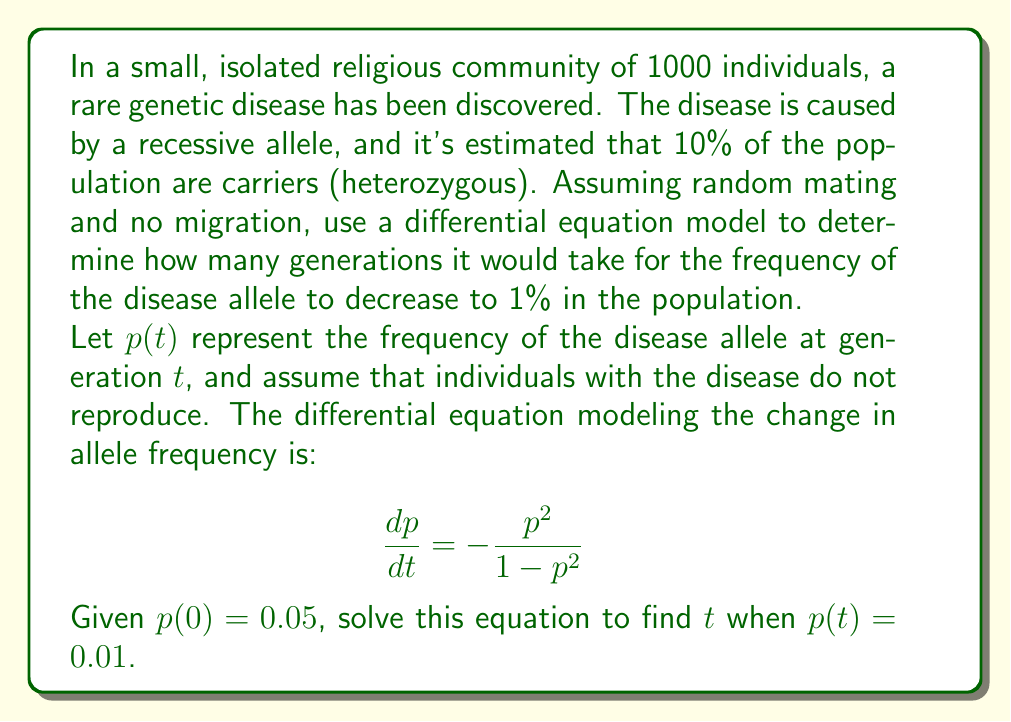Help me with this question. Let's approach this step-by-step:

1) First, we need to separate variables in the differential equation:

   $$\frac{dp}{dt} = -\frac{p^2}{1-p^2}$$
   $$dt = -\frac{1-p^2}{p^2}dp$$

2) Now, we integrate both sides:

   $$\int dt = -\int \frac{1-p^2}{p^2}dp$$

3) The right-hand side can be integrated using partial fractions:

   $$t + C = \frac{1}{p} + \ln(p) + C$$

4) We can determine the constant $C$ using the initial condition $p(0) = 0.05$:

   $$0 = \frac{1}{0.05} + \ln(0.05) + C$$
   $$C = -20 - \ln(0.05) \approx -16.9$$

5) Now our equation is:

   $$t = \frac{1}{p} + \ln(p) + 16.9$$

6) We want to find $t$ when $p = 0.01$. Substituting this:

   $$t = \frac{1}{0.01} + \ln(0.01) + 16.9$$
   $$t = 100 - 4.6 + 16.9 = 112.3$$

7) Since $t$ represents generations, we round up to the nearest whole number.
Answer: 113 generations 